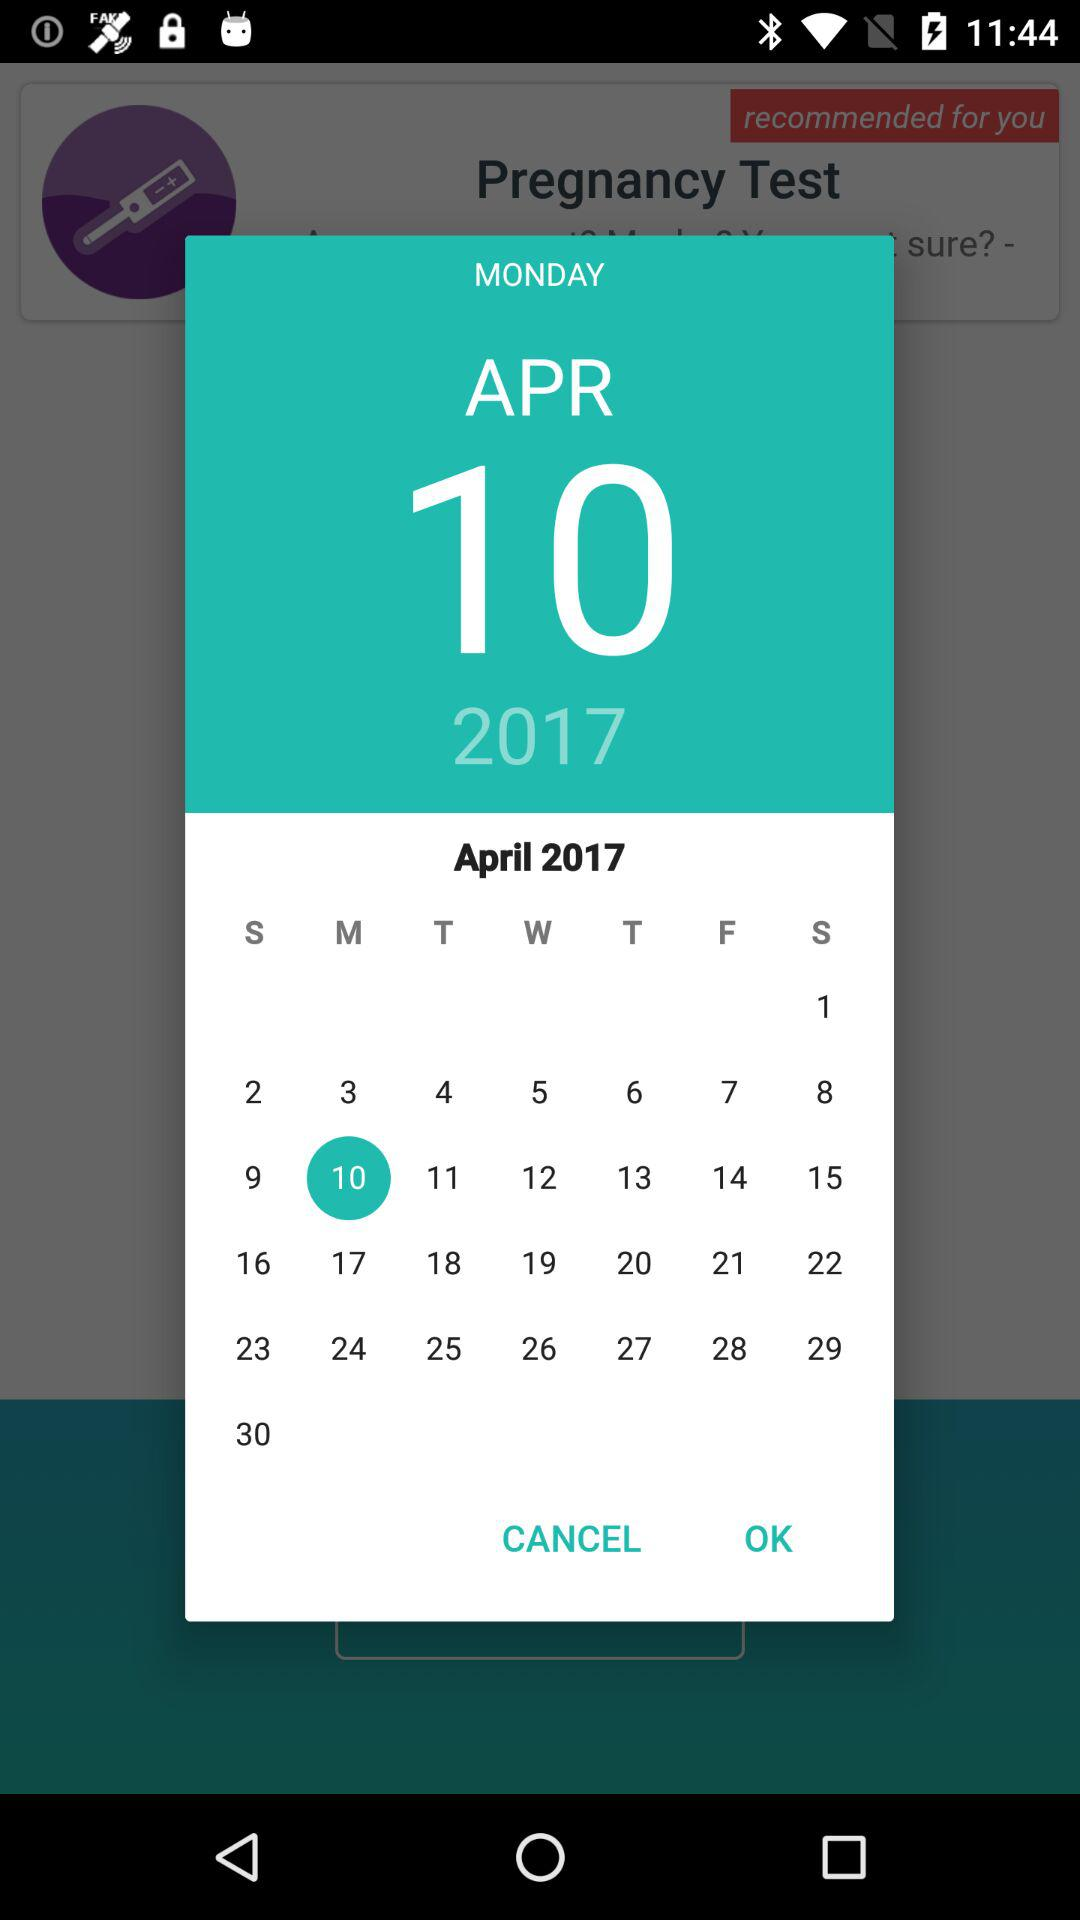What is the selected date? The selected date is Monday, April 10, 2017. 